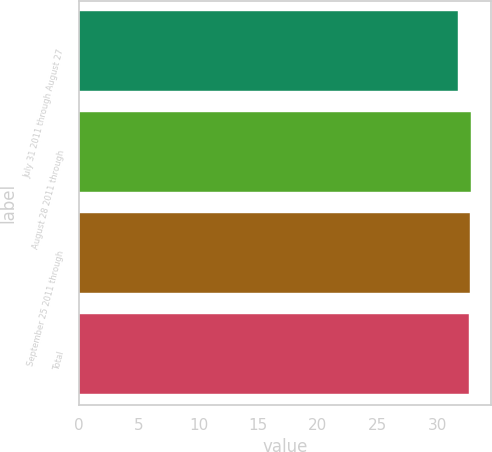Convert chart to OTSL. <chart><loc_0><loc_0><loc_500><loc_500><bar_chart><fcel>July 31 2011 through August 27<fcel>August 28 2011 through<fcel>September 25 2011 through<fcel>Total<nl><fcel>31.72<fcel>32.83<fcel>32.73<fcel>32.63<nl></chart> 